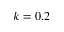<formula> <loc_0><loc_0><loc_500><loc_500>k = 0 . 2</formula> 